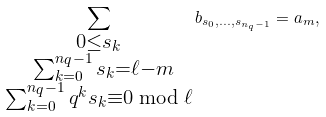<formula> <loc_0><loc_0><loc_500><loc_500>\sum _ { \substack { 0 \leq s _ { k } \\ \ \sum _ { k = 0 } ^ { n _ { q } - 1 } s _ { k } = \ell - m \\ \sum _ { k = 0 } ^ { n _ { q } - 1 } q ^ { k } s _ { k } \equiv 0 \bmod { \ell } } } b _ { s _ { 0 } , \dots , s _ { n _ { q } - 1 } } = a _ { m } ,</formula> 